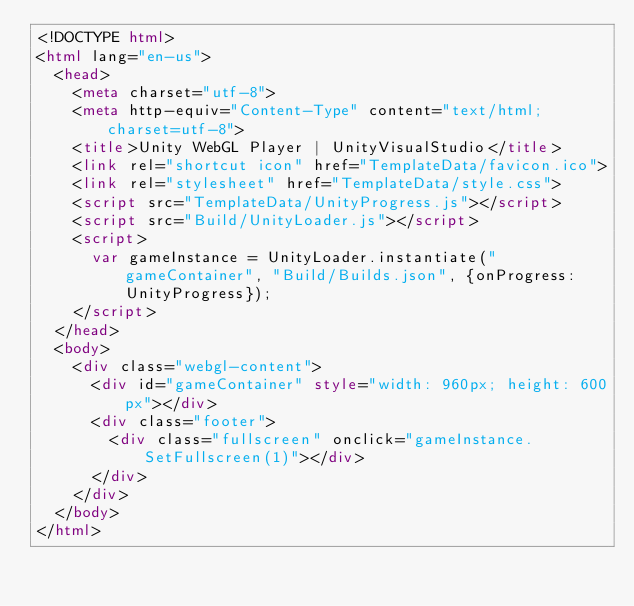Convert code to text. <code><loc_0><loc_0><loc_500><loc_500><_HTML_><!DOCTYPE html>
<html lang="en-us">
  <head>
    <meta charset="utf-8">
    <meta http-equiv="Content-Type" content="text/html; charset=utf-8">
    <title>Unity WebGL Player | UnityVisualStudio</title>
    <link rel="shortcut icon" href="TemplateData/favicon.ico">
    <link rel="stylesheet" href="TemplateData/style.css">
    <script src="TemplateData/UnityProgress.js"></script>  
    <script src="Build/UnityLoader.js"></script>
    <script>
      var gameInstance = UnityLoader.instantiate("gameContainer", "Build/Builds.json", {onProgress: UnityProgress});
    </script>
  </head>
  <body>
    <div class="webgl-content">
      <div id="gameContainer" style="width: 960px; height: 600px"></div>
      <div class="footer">
        <div class="fullscreen" onclick="gameInstance.SetFullscreen(1)"></div>
      </div>
    </div>
  </body>
</html></code> 